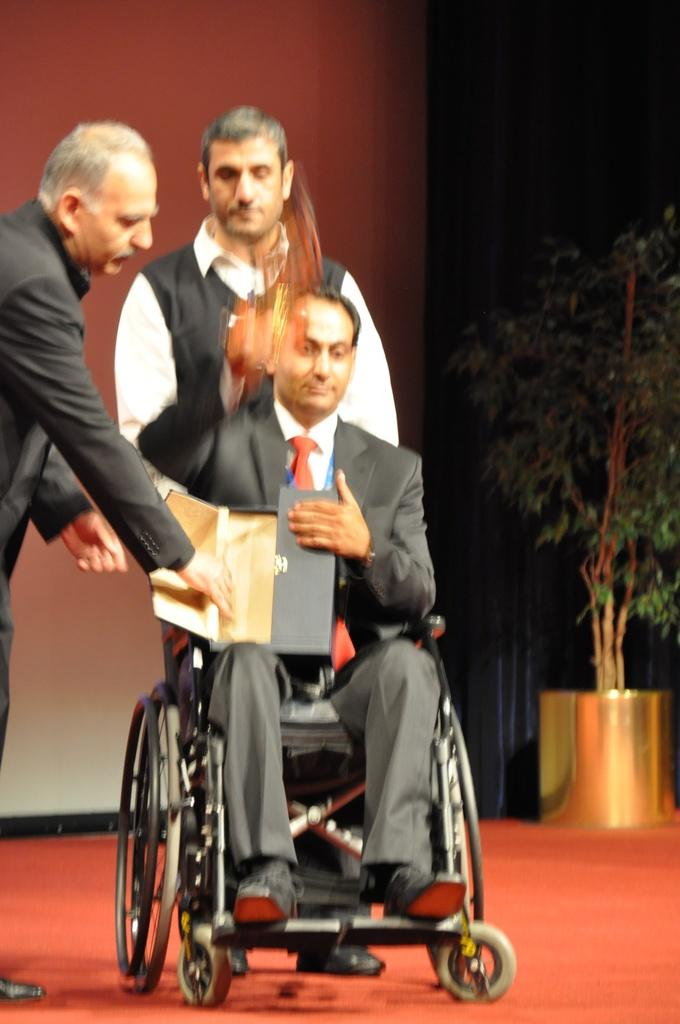How many people are standing in the image? There are two people standing on the floor in the image. What is the man in the image doing? The man is sitting on a chair in the image. What is the man holding? The man is holding a box in the image. What can be seen in the background of the image? There is a plant with a pot in the background of the image. How would you describe the lighting in the image? The background is dark in the image. What type of oatmeal is being served to the fireman in the image? There is no fireman or oatmeal present in the image. How many heads of lettuce are visible on the plant in the image? There is no lettuce visible on the plant in the image; it is a plant with a pot in the background. 